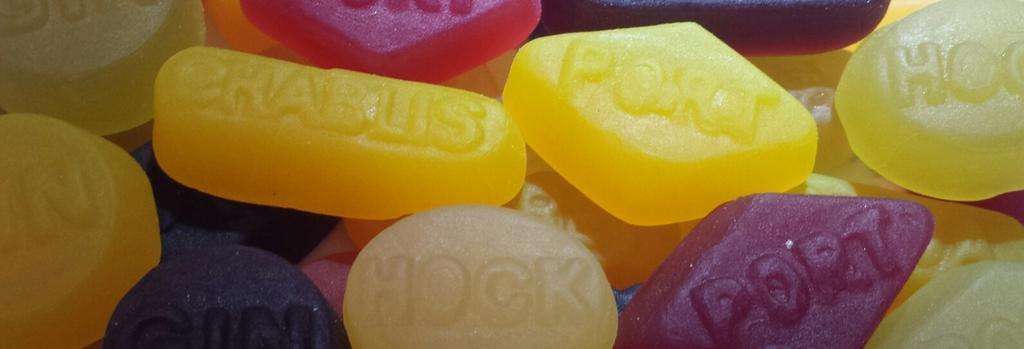Please provide a concise description of this image. In this image there are few candies of different colours are having some text on it. 